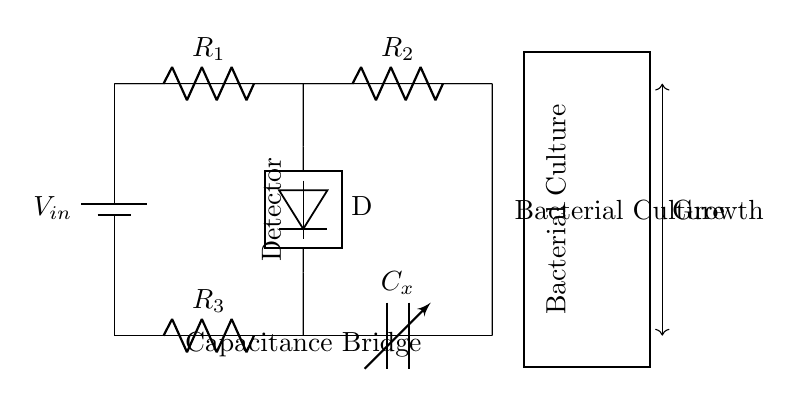What is the input voltage of the circuit? The input voltage is denoted as V_in, which is attached to the top left of the circuit.
Answer: V_in What components are on the left arm of the bridge? The left arm contains two resistors, labeled R_1 and R_2, connected in series between the input voltage and midpoints.
Answer: R_1, R_2 What type of capacitor is used in this circuit? The circuit uses a variable capacitor, indicated by C_x, which is adaptable for detecting variations in capacitance due to bacterial growth.
Answer: Variable capacitor What does the detector measure in this circuit? The detector measures the difference in capacitance caused by bacterial growth in the culture, connecting across the two arms of the bridge at midpoints.
Answer: Capacitance How is the bacterial culture represented in the circuit? The bacterial culture is represented by a rectangular box labeled "Bacterial Culture," indicating the location where the culture is placed for measuring capacitance changes.
Answer: Bacterial Culture Describe the connection between the right arm and the detector. The right arm consists of a resistor R_3 in series with C_x, and they connect to the detector positioned between the midpoints of both arms of the bridge.
Answer: Series connection 